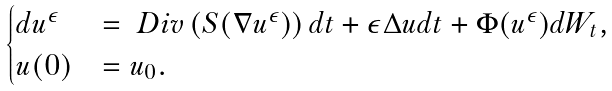Convert formula to latex. <formula><loc_0><loc_0><loc_500><loc_500>\begin{cases} d u ^ { \epsilon } & = \ D i v \left ( S ( \nabla u ^ { \epsilon } ) \right ) d t + \epsilon \Delta u d t + \Phi ( u ^ { \epsilon } ) d W _ { t } , \\ u ( 0 ) & = u _ { 0 } . \end{cases}</formula> 